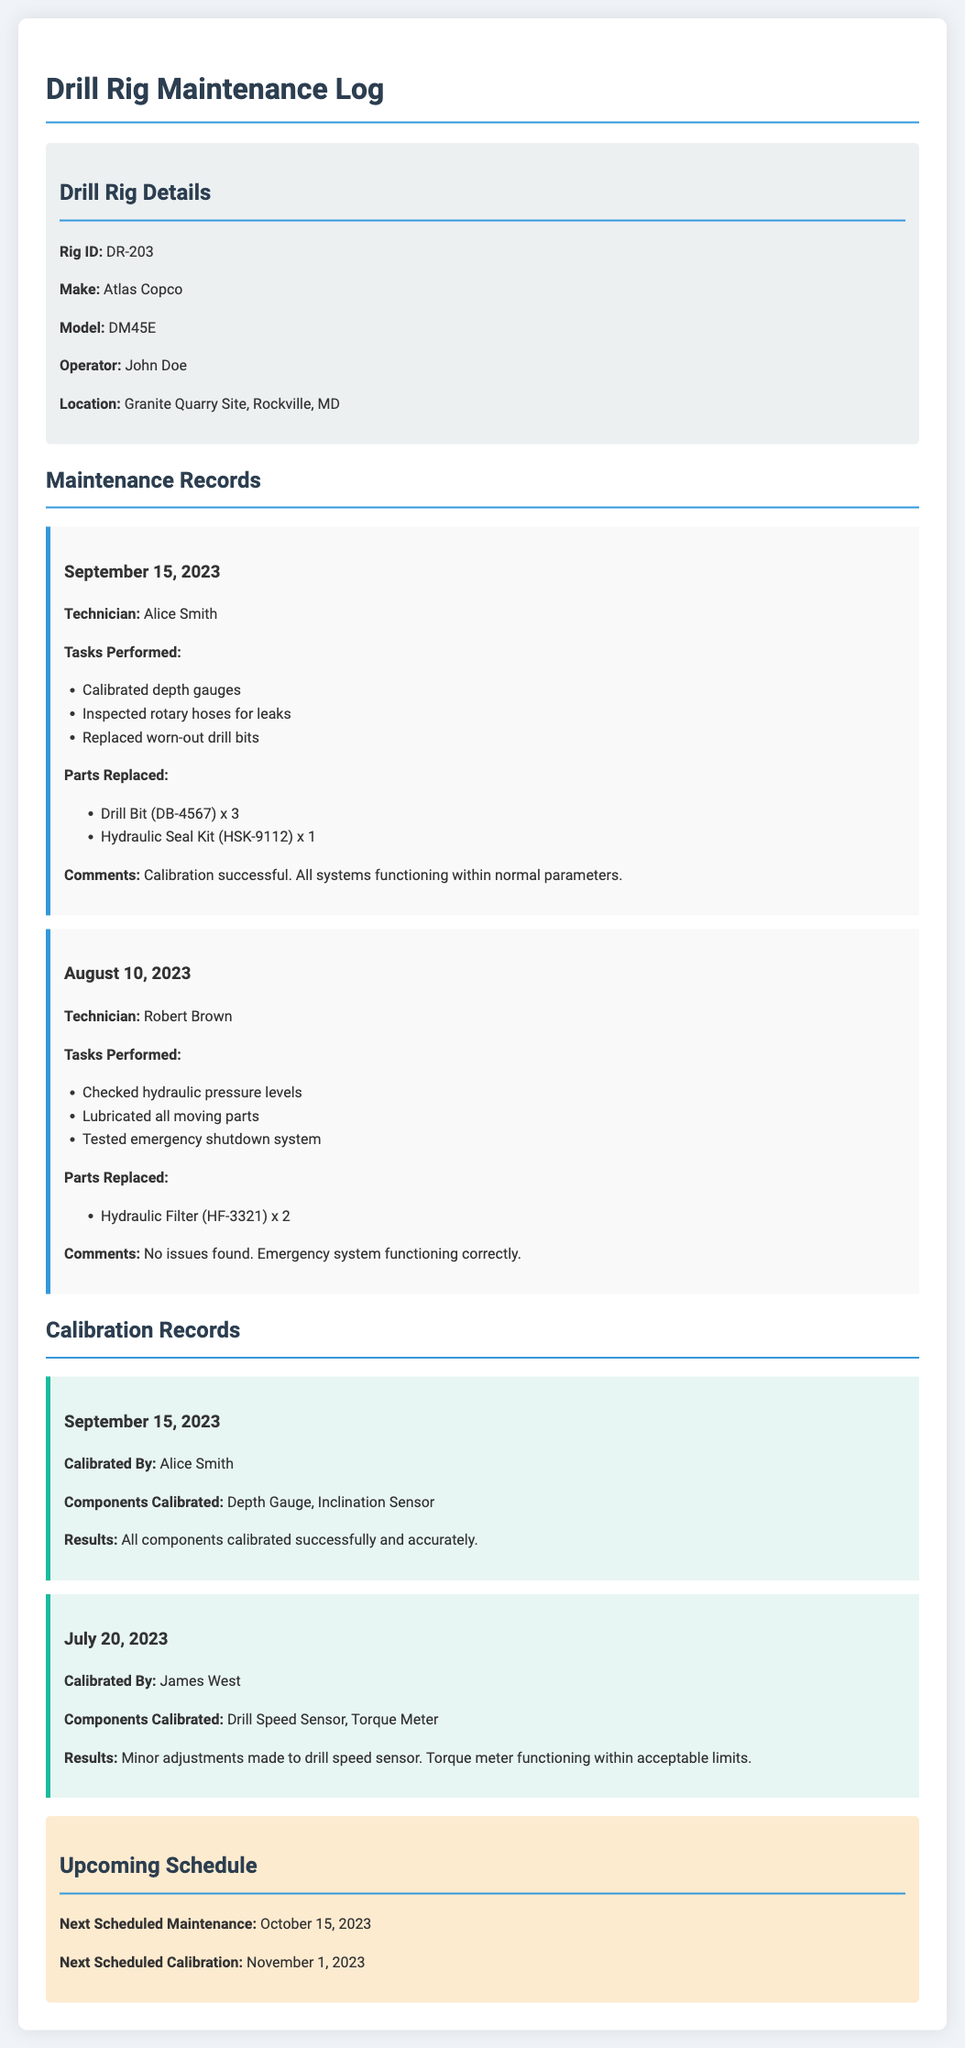What is the Rig ID? The Rig ID is provided in the Drill Rig Details section of the document.
Answer: DR-203 Who calibrated the depth gauges? The technician who performed the calibration is mentioned in the Maintenance Records section.
Answer: Alice Smith What parts were replaced on September 15, 2023? The document lists specific parts replaced during maintenance on that date.
Answer: Drill Bit (DB-4567) x 3, Hydraulic Seal Kit (HSK-9112) x 1 When is the next scheduled calibration? The upcoming schedule section specifies the next scheduled calibration date.
Answer: November 1, 2023 What components were calibrated on July 20, 2023? The calibration records detail which components were calibrated on that date.
Answer: Drill Speed Sensor, Torque Meter What was the comment after the maintenance on August 10, 2023? Comments section captures the results or findings of the maintenance performed.
Answer: No issues found. Emergency system functioning correctly What was performed during the maintenance on September 15, 2023? The tasks performed are listed under the specific maintenance record for that date.
Answer: Calibrated depth gauges, Inspected rotary hoses for leaks, Replaced worn-out drill bits 